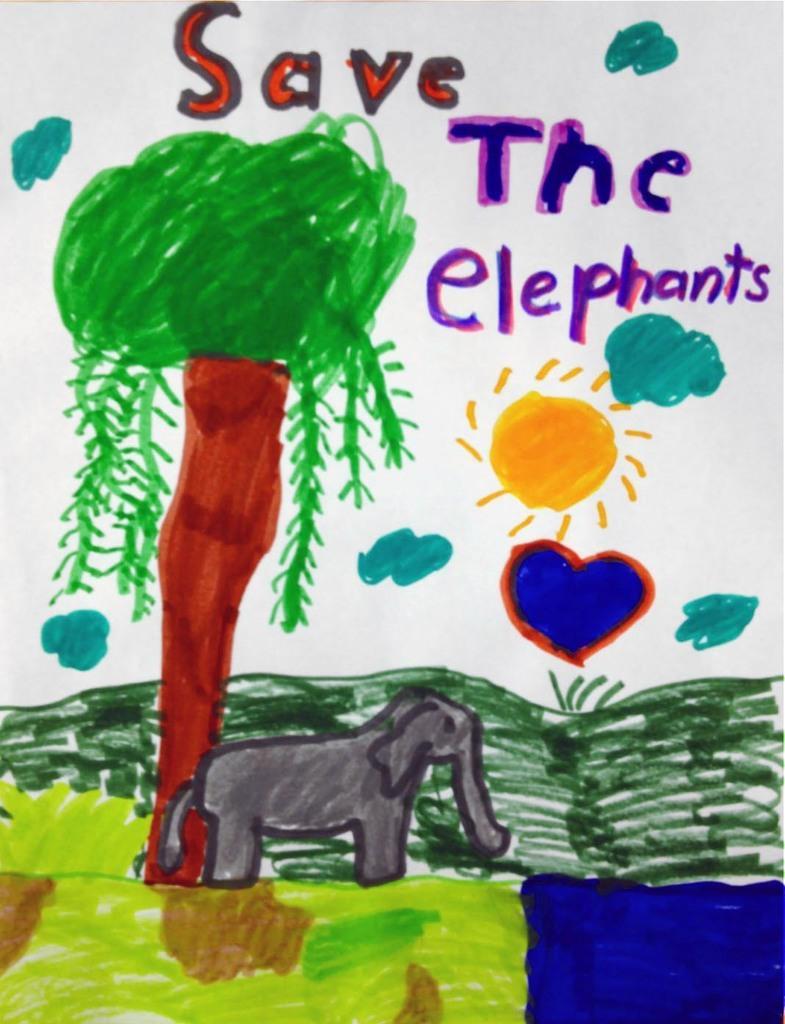Please provide a concise description of this image. This is a painting on the paper. Here we can see a tree, elephant, and text written on it. 